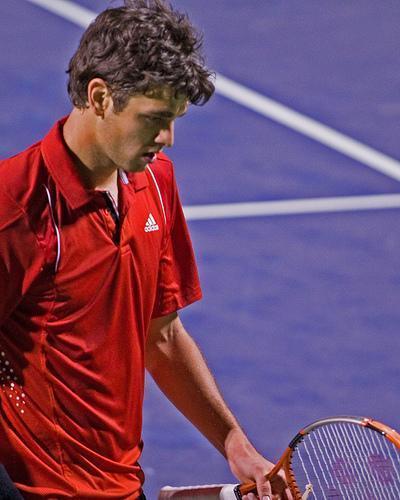How many people are in this photo?
Give a very brief answer. 1. 